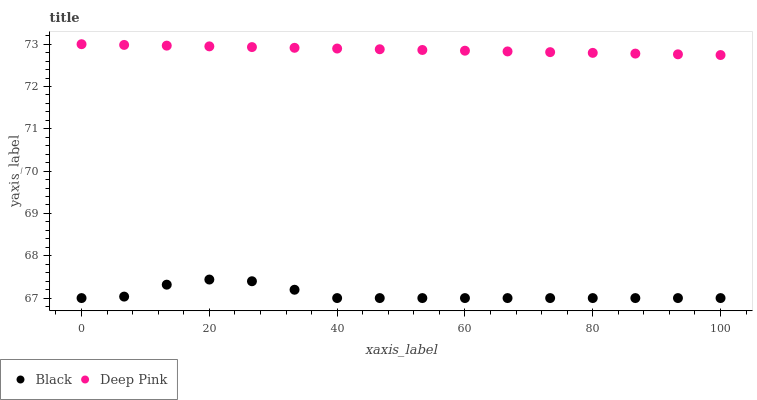Does Black have the minimum area under the curve?
Answer yes or no. Yes. Does Deep Pink have the maximum area under the curve?
Answer yes or no. Yes. Does Black have the maximum area under the curve?
Answer yes or no. No. Is Deep Pink the smoothest?
Answer yes or no. Yes. Is Black the roughest?
Answer yes or no. Yes. Is Black the smoothest?
Answer yes or no. No. Does Black have the lowest value?
Answer yes or no. Yes. Does Deep Pink have the highest value?
Answer yes or no. Yes. Does Black have the highest value?
Answer yes or no. No. Is Black less than Deep Pink?
Answer yes or no. Yes. Is Deep Pink greater than Black?
Answer yes or no. Yes. Does Black intersect Deep Pink?
Answer yes or no. No. 